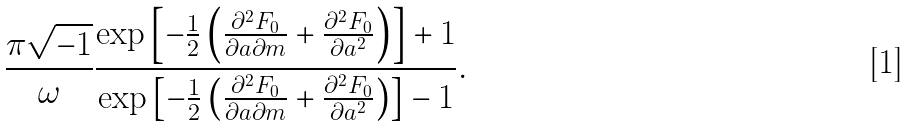Convert formula to latex. <formula><loc_0><loc_0><loc_500><loc_500>\frac { \pi \sqrt { - 1 } } \omega \frac { \exp \left [ - \frac { 1 } { 2 } \left ( \frac { \partial ^ { 2 } F _ { 0 } } { \partial { a } \partial m } + \frac { \partial ^ { 2 } F _ { 0 } } { \partial { a } ^ { 2 } } \right ) \right ] + 1 } { \exp \left [ - \frac { 1 } { 2 } \left ( \frac { \partial ^ { 2 } F _ { 0 } } { \partial { a } \partial m } + \frac { \partial ^ { 2 } F _ { 0 } } { \partial { a } ^ { 2 } } \right ) \right ] - 1 } .</formula> 